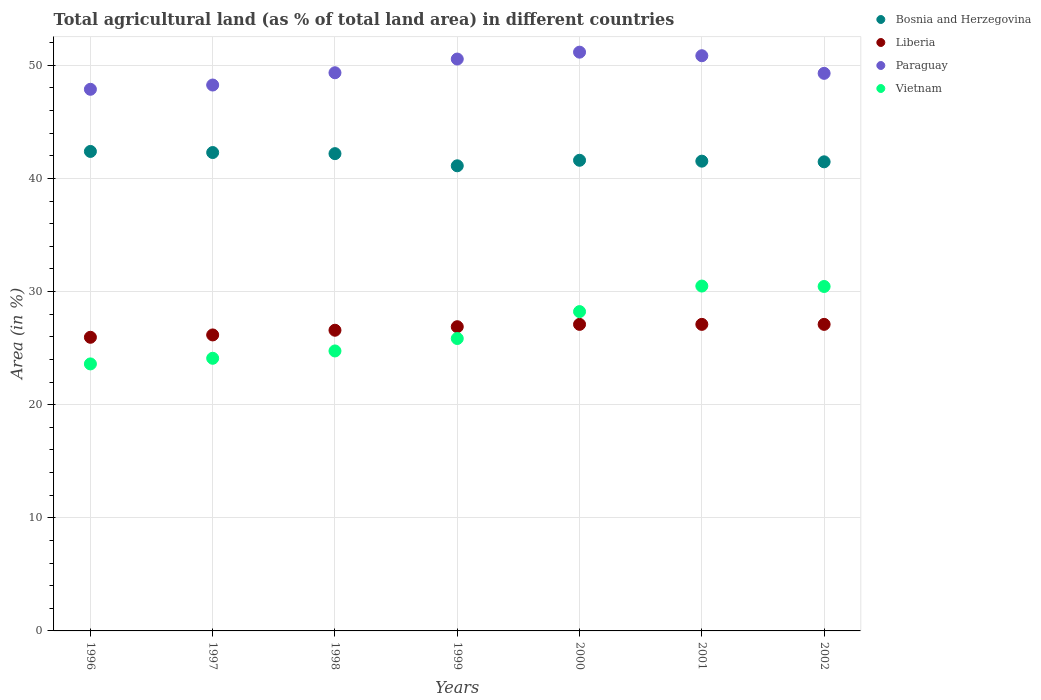How many different coloured dotlines are there?
Give a very brief answer. 4. Is the number of dotlines equal to the number of legend labels?
Provide a short and direct response. Yes. What is the percentage of agricultural land in Paraguay in 2002?
Make the answer very short. 49.29. Across all years, what is the maximum percentage of agricultural land in Vietnam?
Give a very brief answer. 30.48. Across all years, what is the minimum percentage of agricultural land in Liberia?
Provide a succinct answer. 25.96. In which year was the percentage of agricultural land in Paraguay maximum?
Your answer should be very brief. 2000. What is the total percentage of agricultural land in Paraguay in the graph?
Your answer should be compact. 347.3. What is the difference between the percentage of agricultural land in Paraguay in 2000 and that in 2002?
Your answer should be very brief. 1.87. What is the difference between the percentage of agricultural land in Vietnam in 1997 and the percentage of agricultural land in Paraguay in 2000?
Keep it short and to the point. -27.06. What is the average percentage of agricultural land in Vietnam per year?
Give a very brief answer. 26.78. In the year 1996, what is the difference between the percentage of agricultural land in Bosnia and Herzegovina and percentage of agricultural land in Liberia?
Ensure brevity in your answer.  16.43. What is the ratio of the percentage of agricultural land in Bosnia and Herzegovina in 1997 to that in 1998?
Your answer should be compact. 1. What is the difference between the highest and the lowest percentage of agricultural land in Paraguay?
Provide a succinct answer. 3.28. Is the percentage of agricultural land in Bosnia and Herzegovina strictly greater than the percentage of agricultural land in Vietnam over the years?
Your answer should be compact. Yes. Does the graph contain grids?
Make the answer very short. Yes. What is the title of the graph?
Your response must be concise. Total agricultural land (as % of total land area) in different countries. What is the label or title of the X-axis?
Offer a terse response. Years. What is the label or title of the Y-axis?
Provide a succinct answer. Area (in %). What is the Area (in %) in Bosnia and Herzegovina in 1996?
Your response must be concise. 42.38. What is the Area (in %) of Liberia in 1996?
Offer a very short reply. 25.96. What is the Area (in %) in Paraguay in 1996?
Your answer should be very brief. 47.88. What is the Area (in %) of Vietnam in 1996?
Keep it short and to the point. 23.6. What is the Area (in %) of Bosnia and Herzegovina in 1997?
Provide a succinct answer. 42.29. What is the Area (in %) of Liberia in 1997?
Your answer should be very brief. 26.16. What is the Area (in %) of Paraguay in 1997?
Your response must be concise. 48.25. What is the Area (in %) of Vietnam in 1997?
Your response must be concise. 24.1. What is the Area (in %) in Bosnia and Herzegovina in 1998?
Offer a very short reply. 42.19. What is the Area (in %) of Liberia in 1998?
Make the answer very short. 26.58. What is the Area (in %) of Paraguay in 1998?
Give a very brief answer. 49.34. What is the Area (in %) in Vietnam in 1998?
Make the answer very short. 24.75. What is the Area (in %) in Bosnia and Herzegovina in 1999?
Provide a succinct answer. 41.11. What is the Area (in %) of Liberia in 1999?
Your answer should be compact. 26.89. What is the Area (in %) in Paraguay in 1999?
Your answer should be very brief. 50.55. What is the Area (in %) in Vietnam in 1999?
Your answer should be very brief. 25.85. What is the Area (in %) in Bosnia and Herzegovina in 2000?
Offer a terse response. 41.6. What is the Area (in %) in Liberia in 2000?
Give a very brief answer. 27.1. What is the Area (in %) of Paraguay in 2000?
Ensure brevity in your answer.  51.16. What is the Area (in %) of Vietnam in 2000?
Your response must be concise. 28.23. What is the Area (in %) of Bosnia and Herzegovina in 2001?
Your answer should be compact. 41.52. What is the Area (in %) of Liberia in 2001?
Provide a short and direct response. 27.1. What is the Area (in %) of Paraguay in 2001?
Offer a very short reply. 50.84. What is the Area (in %) of Vietnam in 2001?
Your response must be concise. 30.48. What is the Area (in %) of Bosnia and Herzegovina in 2002?
Your response must be concise. 41.46. What is the Area (in %) in Liberia in 2002?
Ensure brevity in your answer.  27.1. What is the Area (in %) in Paraguay in 2002?
Offer a very short reply. 49.29. What is the Area (in %) of Vietnam in 2002?
Provide a succinct answer. 30.45. Across all years, what is the maximum Area (in %) in Bosnia and Herzegovina?
Offer a terse response. 42.38. Across all years, what is the maximum Area (in %) of Liberia?
Ensure brevity in your answer.  27.1. Across all years, what is the maximum Area (in %) of Paraguay?
Ensure brevity in your answer.  51.16. Across all years, what is the maximum Area (in %) of Vietnam?
Provide a succinct answer. 30.48. Across all years, what is the minimum Area (in %) of Bosnia and Herzegovina?
Offer a terse response. 41.11. Across all years, what is the minimum Area (in %) of Liberia?
Keep it short and to the point. 25.96. Across all years, what is the minimum Area (in %) of Paraguay?
Your answer should be very brief. 47.88. Across all years, what is the minimum Area (in %) in Vietnam?
Your answer should be very brief. 23.6. What is the total Area (in %) of Bosnia and Herzegovina in the graph?
Your response must be concise. 292.56. What is the total Area (in %) of Liberia in the graph?
Keep it short and to the point. 186.88. What is the total Area (in %) of Paraguay in the graph?
Ensure brevity in your answer.  347.3. What is the total Area (in %) of Vietnam in the graph?
Offer a terse response. 187.45. What is the difference between the Area (in %) in Bosnia and Herzegovina in 1996 and that in 1997?
Your answer should be very brief. 0.1. What is the difference between the Area (in %) of Liberia in 1996 and that in 1997?
Ensure brevity in your answer.  -0.21. What is the difference between the Area (in %) in Paraguay in 1996 and that in 1997?
Keep it short and to the point. -0.38. What is the difference between the Area (in %) in Vietnam in 1996 and that in 1997?
Give a very brief answer. -0.5. What is the difference between the Area (in %) in Bosnia and Herzegovina in 1996 and that in 1998?
Your response must be concise. 0.2. What is the difference between the Area (in %) in Liberia in 1996 and that in 1998?
Your answer should be compact. -0.62. What is the difference between the Area (in %) in Paraguay in 1996 and that in 1998?
Provide a succinct answer. -1.46. What is the difference between the Area (in %) in Vietnam in 1996 and that in 1998?
Ensure brevity in your answer.  -1.15. What is the difference between the Area (in %) of Bosnia and Herzegovina in 1996 and that in 1999?
Make the answer very short. 1.27. What is the difference between the Area (in %) of Liberia in 1996 and that in 1999?
Provide a short and direct response. -0.93. What is the difference between the Area (in %) in Paraguay in 1996 and that in 1999?
Offer a very short reply. -2.67. What is the difference between the Area (in %) of Vietnam in 1996 and that in 1999?
Provide a short and direct response. -2.25. What is the difference between the Area (in %) in Bosnia and Herzegovina in 1996 and that in 2000?
Provide a succinct answer. 0.78. What is the difference between the Area (in %) of Liberia in 1996 and that in 2000?
Make the answer very short. -1.14. What is the difference between the Area (in %) of Paraguay in 1996 and that in 2000?
Ensure brevity in your answer.  -3.28. What is the difference between the Area (in %) of Vietnam in 1996 and that in 2000?
Provide a succinct answer. -4.62. What is the difference between the Area (in %) of Bosnia and Herzegovina in 1996 and that in 2001?
Provide a short and direct response. 0.86. What is the difference between the Area (in %) in Liberia in 1996 and that in 2001?
Offer a very short reply. -1.14. What is the difference between the Area (in %) in Paraguay in 1996 and that in 2001?
Give a very brief answer. -2.97. What is the difference between the Area (in %) of Vietnam in 1996 and that in 2001?
Keep it short and to the point. -6.88. What is the difference between the Area (in %) of Bosnia and Herzegovina in 1996 and that in 2002?
Your response must be concise. 0.92. What is the difference between the Area (in %) in Liberia in 1996 and that in 2002?
Ensure brevity in your answer.  -1.14. What is the difference between the Area (in %) in Paraguay in 1996 and that in 2002?
Keep it short and to the point. -1.41. What is the difference between the Area (in %) in Vietnam in 1996 and that in 2002?
Ensure brevity in your answer.  -6.84. What is the difference between the Area (in %) of Bosnia and Herzegovina in 1997 and that in 1998?
Provide a succinct answer. 0.1. What is the difference between the Area (in %) in Liberia in 1997 and that in 1998?
Ensure brevity in your answer.  -0.42. What is the difference between the Area (in %) in Paraguay in 1997 and that in 1998?
Provide a short and direct response. -1.08. What is the difference between the Area (in %) in Vietnam in 1997 and that in 1998?
Give a very brief answer. -0.65. What is the difference between the Area (in %) of Bosnia and Herzegovina in 1997 and that in 1999?
Your answer should be very brief. 1.17. What is the difference between the Area (in %) in Liberia in 1997 and that in 1999?
Give a very brief answer. -0.73. What is the difference between the Area (in %) of Paraguay in 1997 and that in 1999?
Give a very brief answer. -2.3. What is the difference between the Area (in %) in Vietnam in 1997 and that in 1999?
Your answer should be compact. -1.75. What is the difference between the Area (in %) in Bosnia and Herzegovina in 1997 and that in 2000?
Keep it short and to the point. 0.68. What is the difference between the Area (in %) of Liberia in 1997 and that in 2000?
Offer a very short reply. -0.93. What is the difference between the Area (in %) in Paraguay in 1997 and that in 2000?
Provide a short and direct response. -2.9. What is the difference between the Area (in %) of Vietnam in 1997 and that in 2000?
Give a very brief answer. -4.13. What is the difference between the Area (in %) in Bosnia and Herzegovina in 1997 and that in 2001?
Keep it short and to the point. 0.76. What is the difference between the Area (in %) in Liberia in 1997 and that in 2001?
Your answer should be very brief. -0.93. What is the difference between the Area (in %) in Paraguay in 1997 and that in 2001?
Offer a terse response. -2.59. What is the difference between the Area (in %) in Vietnam in 1997 and that in 2001?
Make the answer very short. -6.38. What is the difference between the Area (in %) of Bosnia and Herzegovina in 1997 and that in 2002?
Offer a very short reply. 0.82. What is the difference between the Area (in %) of Liberia in 1997 and that in 2002?
Ensure brevity in your answer.  -0.93. What is the difference between the Area (in %) in Paraguay in 1997 and that in 2002?
Keep it short and to the point. -1.03. What is the difference between the Area (in %) in Vietnam in 1997 and that in 2002?
Make the answer very short. -6.35. What is the difference between the Area (in %) of Bosnia and Herzegovina in 1998 and that in 1999?
Provide a short and direct response. 1.07. What is the difference between the Area (in %) of Liberia in 1998 and that in 1999?
Provide a succinct answer. -0.31. What is the difference between the Area (in %) of Paraguay in 1998 and that in 1999?
Your response must be concise. -1.21. What is the difference between the Area (in %) in Vietnam in 1998 and that in 1999?
Give a very brief answer. -1.1. What is the difference between the Area (in %) of Bosnia and Herzegovina in 1998 and that in 2000?
Keep it short and to the point. 0.59. What is the difference between the Area (in %) of Liberia in 1998 and that in 2000?
Your answer should be compact. -0.52. What is the difference between the Area (in %) in Paraguay in 1998 and that in 2000?
Offer a very short reply. -1.82. What is the difference between the Area (in %) in Vietnam in 1998 and that in 2000?
Ensure brevity in your answer.  -3.48. What is the difference between the Area (in %) of Bosnia and Herzegovina in 1998 and that in 2001?
Your response must be concise. 0.66. What is the difference between the Area (in %) in Liberia in 1998 and that in 2001?
Keep it short and to the point. -0.52. What is the difference between the Area (in %) of Paraguay in 1998 and that in 2001?
Give a very brief answer. -1.51. What is the difference between the Area (in %) of Vietnam in 1998 and that in 2001?
Provide a short and direct response. -5.74. What is the difference between the Area (in %) of Bosnia and Herzegovina in 1998 and that in 2002?
Offer a very short reply. 0.72. What is the difference between the Area (in %) of Liberia in 1998 and that in 2002?
Ensure brevity in your answer.  -0.52. What is the difference between the Area (in %) of Paraguay in 1998 and that in 2002?
Ensure brevity in your answer.  0.05. What is the difference between the Area (in %) of Vietnam in 1998 and that in 2002?
Your answer should be very brief. -5.7. What is the difference between the Area (in %) in Bosnia and Herzegovina in 1999 and that in 2000?
Your response must be concise. -0.49. What is the difference between the Area (in %) of Liberia in 1999 and that in 2000?
Your answer should be compact. -0.21. What is the difference between the Area (in %) of Paraguay in 1999 and that in 2000?
Your answer should be compact. -0.61. What is the difference between the Area (in %) of Vietnam in 1999 and that in 2000?
Your answer should be compact. -2.38. What is the difference between the Area (in %) of Bosnia and Herzegovina in 1999 and that in 2001?
Provide a succinct answer. -0.41. What is the difference between the Area (in %) of Liberia in 1999 and that in 2001?
Keep it short and to the point. -0.21. What is the difference between the Area (in %) of Paraguay in 1999 and that in 2001?
Give a very brief answer. -0.29. What is the difference between the Area (in %) of Vietnam in 1999 and that in 2001?
Offer a terse response. -4.64. What is the difference between the Area (in %) in Bosnia and Herzegovina in 1999 and that in 2002?
Keep it short and to the point. -0.35. What is the difference between the Area (in %) of Liberia in 1999 and that in 2002?
Provide a succinct answer. -0.21. What is the difference between the Area (in %) of Paraguay in 1999 and that in 2002?
Your answer should be very brief. 1.26. What is the difference between the Area (in %) in Vietnam in 1999 and that in 2002?
Your answer should be very brief. -4.6. What is the difference between the Area (in %) of Bosnia and Herzegovina in 2000 and that in 2001?
Keep it short and to the point. 0.08. What is the difference between the Area (in %) of Liberia in 2000 and that in 2001?
Offer a very short reply. 0. What is the difference between the Area (in %) in Paraguay in 2000 and that in 2001?
Your response must be concise. 0.31. What is the difference between the Area (in %) in Vietnam in 2000 and that in 2001?
Offer a very short reply. -2.26. What is the difference between the Area (in %) in Bosnia and Herzegovina in 2000 and that in 2002?
Your answer should be compact. 0.14. What is the difference between the Area (in %) in Liberia in 2000 and that in 2002?
Ensure brevity in your answer.  0. What is the difference between the Area (in %) of Paraguay in 2000 and that in 2002?
Provide a short and direct response. 1.87. What is the difference between the Area (in %) in Vietnam in 2000 and that in 2002?
Your answer should be very brief. -2.22. What is the difference between the Area (in %) of Bosnia and Herzegovina in 2001 and that in 2002?
Your response must be concise. 0.06. What is the difference between the Area (in %) in Liberia in 2001 and that in 2002?
Provide a short and direct response. 0. What is the difference between the Area (in %) in Paraguay in 2001 and that in 2002?
Offer a very short reply. 1.56. What is the difference between the Area (in %) of Vietnam in 2001 and that in 2002?
Provide a short and direct response. 0.04. What is the difference between the Area (in %) of Bosnia and Herzegovina in 1996 and the Area (in %) of Liberia in 1997?
Provide a short and direct response. 16.22. What is the difference between the Area (in %) of Bosnia and Herzegovina in 1996 and the Area (in %) of Paraguay in 1997?
Offer a terse response. -5.87. What is the difference between the Area (in %) of Bosnia and Herzegovina in 1996 and the Area (in %) of Vietnam in 1997?
Your answer should be compact. 18.28. What is the difference between the Area (in %) of Liberia in 1996 and the Area (in %) of Paraguay in 1997?
Offer a very short reply. -22.3. What is the difference between the Area (in %) in Liberia in 1996 and the Area (in %) in Vietnam in 1997?
Make the answer very short. 1.86. What is the difference between the Area (in %) of Paraguay in 1996 and the Area (in %) of Vietnam in 1997?
Your answer should be compact. 23.78. What is the difference between the Area (in %) of Bosnia and Herzegovina in 1996 and the Area (in %) of Liberia in 1998?
Provide a short and direct response. 15.8. What is the difference between the Area (in %) of Bosnia and Herzegovina in 1996 and the Area (in %) of Paraguay in 1998?
Your response must be concise. -6.96. What is the difference between the Area (in %) in Bosnia and Herzegovina in 1996 and the Area (in %) in Vietnam in 1998?
Your response must be concise. 17.64. What is the difference between the Area (in %) in Liberia in 1996 and the Area (in %) in Paraguay in 1998?
Give a very brief answer. -23.38. What is the difference between the Area (in %) of Liberia in 1996 and the Area (in %) of Vietnam in 1998?
Your answer should be compact. 1.21. What is the difference between the Area (in %) in Paraguay in 1996 and the Area (in %) in Vietnam in 1998?
Your response must be concise. 23.13. What is the difference between the Area (in %) of Bosnia and Herzegovina in 1996 and the Area (in %) of Liberia in 1999?
Provide a short and direct response. 15.49. What is the difference between the Area (in %) in Bosnia and Herzegovina in 1996 and the Area (in %) in Paraguay in 1999?
Your response must be concise. -8.17. What is the difference between the Area (in %) in Bosnia and Herzegovina in 1996 and the Area (in %) in Vietnam in 1999?
Your answer should be very brief. 16.54. What is the difference between the Area (in %) in Liberia in 1996 and the Area (in %) in Paraguay in 1999?
Give a very brief answer. -24.59. What is the difference between the Area (in %) of Liberia in 1996 and the Area (in %) of Vietnam in 1999?
Your answer should be compact. 0.11. What is the difference between the Area (in %) of Paraguay in 1996 and the Area (in %) of Vietnam in 1999?
Offer a very short reply. 22.03. What is the difference between the Area (in %) in Bosnia and Herzegovina in 1996 and the Area (in %) in Liberia in 2000?
Keep it short and to the point. 15.29. What is the difference between the Area (in %) in Bosnia and Herzegovina in 1996 and the Area (in %) in Paraguay in 2000?
Provide a succinct answer. -8.78. What is the difference between the Area (in %) in Bosnia and Herzegovina in 1996 and the Area (in %) in Vietnam in 2000?
Your answer should be compact. 14.16. What is the difference between the Area (in %) in Liberia in 1996 and the Area (in %) in Paraguay in 2000?
Provide a succinct answer. -25.2. What is the difference between the Area (in %) of Liberia in 1996 and the Area (in %) of Vietnam in 2000?
Your answer should be very brief. -2.27. What is the difference between the Area (in %) in Paraguay in 1996 and the Area (in %) in Vietnam in 2000?
Provide a short and direct response. 19.65. What is the difference between the Area (in %) in Bosnia and Herzegovina in 1996 and the Area (in %) in Liberia in 2001?
Provide a succinct answer. 15.29. What is the difference between the Area (in %) of Bosnia and Herzegovina in 1996 and the Area (in %) of Paraguay in 2001?
Ensure brevity in your answer.  -8.46. What is the difference between the Area (in %) in Bosnia and Herzegovina in 1996 and the Area (in %) in Vietnam in 2001?
Provide a succinct answer. 11.9. What is the difference between the Area (in %) of Liberia in 1996 and the Area (in %) of Paraguay in 2001?
Your answer should be very brief. -24.89. What is the difference between the Area (in %) in Liberia in 1996 and the Area (in %) in Vietnam in 2001?
Your answer should be very brief. -4.53. What is the difference between the Area (in %) of Paraguay in 1996 and the Area (in %) of Vietnam in 2001?
Your answer should be compact. 17.39. What is the difference between the Area (in %) of Bosnia and Herzegovina in 1996 and the Area (in %) of Liberia in 2002?
Ensure brevity in your answer.  15.29. What is the difference between the Area (in %) in Bosnia and Herzegovina in 1996 and the Area (in %) in Paraguay in 2002?
Make the answer very short. -6.9. What is the difference between the Area (in %) of Bosnia and Herzegovina in 1996 and the Area (in %) of Vietnam in 2002?
Keep it short and to the point. 11.94. What is the difference between the Area (in %) of Liberia in 1996 and the Area (in %) of Paraguay in 2002?
Offer a terse response. -23.33. What is the difference between the Area (in %) of Liberia in 1996 and the Area (in %) of Vietnam in 2002?
Your answer should be compact. -4.49. What is the difference between the Area (in %) of Paraguay in 1996 and the Area (in %) of Vietnam in 2002?
Your response must be concise. 17.43. What is the difference between the Area (in %) of Bosnia and Herzegovina in 1997 and the Area (in %) of Liberia in 1998?
Make the answer very short. 15.71. What is the difference between the Area (in %) of Bosnia and Herzegovina in 1997 and the Area (in %) of Paraguay in 1998?
Give a very brief answer. -7.05. What is the difference between the Area (in %) of Bosnia and Herzegovina in 1997 and the Area (in %) of Vietnam in 1998?
Your answer should be compact. 17.54. What is the difference between the Area (in %) of Liberia in 1997 and the Area (in %) of Paraguay in 1998?
Offer a terse response. -23.18. What is the difference between the Area (in %) in Liberia in 1997 and the Area (in %) in Vietnam in 1998?
Make the answer very short. 1.42. What is the difference between the Area (in %) in Paraguay in 1997 and the Area (in %) in Vietnam in 1998?
Keep it short and to the point. 23.51. What is the difference between the Area (in %) of Bosnia and Herzegovina in 1997 and the Area (in %) of Liberia in 1999?
Provide a succinct answer. 15.4. What is the difference between the Area (in %) in Bosnia and Herzegovina in 1997 and the Area (in %) in Paraguay in 1999?
Provide a succinct answer. -8.26. What is the difference between the Area (in %) in Bosnia and Herzegovina in 1997 and the Area (in %) in Vietnam in 1999?
Your response must be concise. 16.44. What is the difference between the Area (in %) of Liberia in 1997 and the Area (in %) of Paraguay in 1999?
Make the answer very short. -24.39. What is the difference between the Area (in %) in Liberia in 1997 and the Area (in %) in Vietnam in 1999?
Provide a succinct answer. 0.32. What is the difference between the Area (in %) in Paraguay in 1997 and the Area (in %) in Vietnam in 1999?
Keep it short and to the point. 22.41. What is the difference between the Area (in %) of Bosnia and Herzegovina in 1997 and the Area (in %) of Liberia in 2000?
Make the answer very short. 15.19. What is the difference between the Area (in %) of Bosnia and Herzegovina in 1997 and the Area (in %) of Paraguay in 2000?
Your answer should be very brief. -8.87. What is the difference between the Area (in %) in Bosnia and Herzegovina in 1997 and the Area (in %) in Vietnam in 2000?
Your answer should be very brief. 14.06. What is the difference between the Area (in %) in Liberia in 1997 and the Area (in %) in Paraguay in 2000?
Your answer should be very brief. -25. What is the difference between the Area (in %) in Liberia in 1997 and the Area (in %) in Vietnam in 2000?
Your answer should be compact. -2.06. What is the difference between the Area (in %) of Paraguay in 1997 and the Area (in %) of Vietnam in 2000?
Provide a short and direct response. 20.03. What is the difference between the Area (in %) in Bosnia and Herzegovina in 1997 and the Area (in %) in Liberia in 2001?
Give a very brief answer. 15.19. What is the difference between the Area (in %) of Bosnia and Herzegovina in 1997 and the Area (in %) of Paraguay in 2001?
Provide a succinct answer. -8.56. What is the difference between the Area (in %) of Bosnia and Herzegovina in 1997 and the Area (in %) of Vietnam in 2001?
Ensure brevity in your answer.  11.8. What is the difference between the Area (in %) in Liberia in 1997 and the Area (in %) in Paraguay in 2001?
Your answer should be compact. -24.68. What is the difference between the Area (in %) of Liberia in 1997 and the Area (in %) of Vietnam in 2001?
Provide a short and direct response. -4.32. What is the difference between the Area (in %) of Paraguay in 1997 and the Area (in %) of Vietnam in 2001?
Provide a short and direct response. 17.77. What is the difference between the Area (in %) of Bosnia and Herzegovina in 1997 and the Area (in %) of Liberia in 2002?
Provide a short and direct response. 15.19. What is the difference between the Area (in %) in Bosnia and Herzegovina in 1997 and the Area (in %) in Paraguay in 2002?
Keep it short and to the point. -7. What is the difference between the Area (in %) in Bosnia and Herzegovina in 1997 and the Area (in %) in Vietnam in 2002?
Give a very brief answer. 11.84. What is the difference between the Area (in %) of Liberia in 1997 and the Area (in %) of Paraguay in 2002?
Your answer should be compact. -23.12. What is the difference between the Area (in %) in Liberia in 1997 and the Area (in %) in Vietnam in 2002?
Your answer should be very brief. -4.28. What is the difference between the Area (in %) in Paraguay in 1997 and the Area (in %) in Vietnam in 2002?
Provide a short and direct response. 17.81. What is the difference between the Area (in %) in Bosnia and Herzegovina in 1998 and the Area (in %) in Liberia in 1999?
Keep it short and to the point. 15.3. What is the difference between the Area (in %) in Bosnia and Herzegovina in 1998 and the Area (in %) in Paraguay in 1999?
Offer a very short reply. -8.36. What is the difference between the Area (in %) of Bosnia and Herzegovina in 1998 and the Area (in %) of Vietnam in 1999?
Your answer should be very brief. 16.34. What is the difference between the Area (in %) of Liberia in 1998 and the Area (in %) of Paraguay in 1999?
Your answer should be compact. -23.97. What is the difference between the Area (in %) of Liberia in 1998 and the Area (in %) of Vietnam in 1999?
Provide a short and direct response. 0.73. What is the difference between the Area (in %) of Paraguay in 1998 and the Area (in %) of Vietnam in 1999?
Your response must be concise. 23.49. What is the difference between the Area (in %) in Bosnia and Herzegovina in 1998 and the Area (in %) in Liberia in 2000?
Provide a short and direct response. 15.09. What is the difference between the Area (in %) in Bosnia and Herzegovina in 1998 and the Area (in %) in Paraguay in 2000?
Your answer should be very brief. -8.97. What is the difference between the Area (in %) of Bosnia and Herzegovina in 1998 and the Area (in %) of Vietnam in 2000?
Your response must be concise. 13.96. What is the difference between the Area (in %) of Liberia in 1998 and the Area (in %) of Paraguay in 2000?
Provide a succinct answer. -24.58. What is the difference between the Area (in %) of Liberia in 1998 and the Area (in %) of Vietnam in 2000?
Give a very brief answer. -1.65. What is the difference between the Area (in %) of Paraguay in 1998 and the Area (in %) of Vietnam in 2000?
Give a very brief answer. 21.11. What is the difference between the Area (in %) in Bosnia and Herzegovina in 1998 and the Area (in %) in Liberia in 2001?
Keep it short and to the point. 15.09. What is the difference between the Area (in %) in Bosnia and Herzegovina in 1998 and the Area (in %) in Paraguay in 2001?
Provide a succinct answer. -8.66. What is the difference between the Area (in %) in Bosnia and Herzegovina in 1998 and the Area (in %) in Vietnam in 2001?
Provide a short and direct response. 11.7. What is the difference between the Area (in %) in Liberia in 1998 and the Area (in %) in Paraguay in 2001?
Make the answer very short. -24.27. What is the difference between the Area (in %) of Liberia in 1998 and the Area (in %) of Vietnam in 2001?
Offer a terse response. -3.91. What is the difference between the Area (in %) of Paraguay in 1998 and the Area (in %) of Vietnam in 2001?
Your response must be concise. 18.85. What is the difference between the Area (in %) in Bosnia and Herzegovina in 1998 and the Area (in %) in Liberia in 2002?
Provide a short and direct response. 15.09. What is the difference between the Area (in %) in Bosnia and Herzegovina in 1998 and the Area (in %) in Paraguay in 2002?
Offer a very short reply. -7.1. What is the difference between the Area (in %) in Bosnia and Herzegovina in 1998 and the Area (in %) in Vietnam in 2002?
Offer a terse response. 11.74. What is the difference between the Area (in %) in Liberia in 1998 and the Area (in %) in Paraguay in 2002?
Your response must be concise. -22.71. What is the difference between the Area (in %) in Liberia in 1998 and the Area (in %) in Vietnam in 2002?
Your response must be concise. -3.87. What is the difference between the Area (in %) of Paraguay in 1998 and the Area (in %) of Vietnam in 2002?
Give a very brief answer. 18.89. What is the difference between the Area (in %) in Bosnia and Herzegovina in 1999 and the Area (in %) in Liberia in 2000?
Provide a short and direct response. 14.02. What is the difference between the Area (in %) in Bosnia and Herzegovina in 1999 and the Area (in %) in Paraguay in 2000?
Offer a very short reply. -10.04. What is the difference between the Area (in %) of Bosnia and Herzegovina in 1999 and the Area (in %) of Vietnam in 2000?
Your answer should be compact. 12.89. What is the difference between the Area (in %) in Liberia in 1999 and the Area (in %) in Paraguay in 2000?
Provide a succinct answer. -24.27. What is the difference between the Area (in %) in Liberia in 1999 and the Area (in %) in Vietnam in 2000?
Give a very brief answer. -1.34. What is the difference between the Area (in %) in Paraguay in 1999 and the Area (in %) in Vietnam in 2000?
Give a very brief answer. 22.32. What is the difference between the Area (in %) of Bosnia and Herzegovina in 1999 and the Area (in %) of Liberia in 2001?
Your answer should be very brief. 14.02. What is the difference between the Area (in %) of Bosnia and Herzegovina in 1999 and the Area (in %) of Paraguay in 2001?
Offer a terse response. -9.73. What is the difference between the Area (in %) in Bosnia and Herzegovina in 1999 and the Area (in %) in Vietnam in 2001?
Your answer should be very brief. 10.63. What is the difference between the Area (in %) in Liberia in 1999 and the Area (in %) in Paraguay in 2001?
Offer a terse response. -23.95. What is the difference between the Area (in %) of Liberia in 1999 and the Area (in %) of Vietnam in 2001?
Make the answer very short. -3.59. What is the difference between the Area (in %) in Paraguay in 1999 and the Area (in %) in Vietnam in 2001?
Provide a succinct answer. 20.07. What is the difference between the Area (in %) in Bosnia and Herzegovina in 1999 and the Area (in %) in Liberia in 2002?
Your answer should be very brief. 14.02. What is the difference between the Area (in %) in Bosnia and Herzegovina in 1999 and the Area (in %) in Paraguay in 2002?
Make the answer very short. -8.17. What is the difference between the Area (in %) in Bosnia and Herzegovina in 1999 and the Area (in %) in Vietnam in 2002?
Provide a short and direct response. 10.67. What is the difference between the Area (in %) in Liberia in 1999 and the Area (in %) in Paraguay in 2002?
Keep it short and to the point. -22.4. What is the difference between the Area (in %) in Liberia in 1999 and the Area (in %) in Vietnam in 2002?
Your response must be concise. -3.56. What is the difference between the Area (in %) in Paraguay in 1999 and the Area (in %) in Vietnam in 2002?
Provide a short and direct response. 20.1. What is the difference between the Area (in %) of Bosnia and Herzegovina in 2000 and the Area (in %) of Liberia in 2001?
Make the answer very short. 14.5. What is the difference between the Area (in %) of Bosnia and Herzegovina in 2000 and the Area (in %) of Paraguay in 2001?
Your answer should be very brief. -9.24. What is the difference between the Area (in %) in Bosnia and Herzegovina in 2000 and the Area (in %) in Vietnam in 2001?
Your answer should be compact. 11.12. What is the difference between the Area (in %) in Liberia in 2000 and the Area (in %) in Paraguay in 2001?
Provide a succinct answer. -23.75. What is the difference between the Area (in %) in Liberia in 2000 and the Area (in %) in Vietnam in 2001?
Make the answer very short. -3.39. What is the difference between the Area (in %) of Paraguay in 2000 and the Area (in %) of Vietnam in 2001?
Ensure brevity in your answer.  20.67. What is the difference between the Area (in %) of Bosnia and Herzegovina in 2000 and the Area (in %) of Liberia in 2002?
Your answer should be very brief. 14.5. What is the difference between the Area (in %) of Bosnia and Herzegovina in 2000 and the Area (in %) of Paraguay in 2002?
Make the answer very short. -7.68. What is the difference between the Area (in %) of Bosnia and Herzegovina in 2000 and the Area (in %) of Vietnam in 2002?
Provide a short and direct response. 11.16. What is the difference between the Area (in %) of Liberia in 2000 and the Area (in %) of Paraguay in 2002?
Ensure brevity in your answer.  -22.19. What is the difference between the Area (in %) in Liberia in 2000 and the Area (in %) in Vietnam in 2002?
Provide a succinct answer. -3.35. What is the difference between the Area (in %) in Paraguay in 2000 and the Area (in %) in Vietnam in 2002?
Your answer should be compact. 20.71. What is the difference between the Area (in %) of Bosnia and Herzegovina in 2001 and the Area (in %) of Liberia in 2002?
Your answer should be compact. 14.43. What is the difference between the Area (in %) of Bosnia and Herzegovina in 2001 and the Area (in %) of Paraguay in 2002?
Provide a short and direct response. -7.76. What is the difference between the Area (in %) in Bosnia and Herzegovina in 2001 and the Area (in %) in Vietnam in 2002?
Your answer should be compact. 11.08. What is the difference between the Area (in %) of Liberia in 2001 and the Area (in %) of Paraguay in 2002?
Your answer should be compact. -22.19. What is the difference between the Area (in %) in Liberia in 2001 and the Area (in %) in Vietnam in 2002?
Make the answer very short. -3.35. What is the difference between the Area (in %) of Paraguay in 2001 and the Area (in %) of Vietnam in 2002?
Provide a succinct answer. 20.4. What is the average Area (in %) of Bosnia and Herzegovina per year?
Give a very brief answer. 41.79. What is the average Area (in %) in Liberia per year?
Give a very brief answer. 26.7. What is the average Area (in %) in Paraguay per year?
Your response must be concise. 49.61. What is the average Area (in %) of Vietnam per year?
Your response must be concise. 26.78. In the year 1996, what is the difference between the Area (in %) of Bosnia and Herzegovina and Area (in %) of Liberia?
Your answer should be very brief. 16.43. In the year 1996, what is the difference between the Area (in %) of Bosnia and Herzegovina and Area (in %) of Paraguay?
Provide a short and direct response. -5.49. In the year 1996, what is the difference between the Area (in %) of Bosnia and Herzegovina and Area (in %) of Vietnam?
Provide a short and direct response. 18.78. In the year 1996, what is the difference between the Area (in %) in Liberia and Area (in %) in Paraguay?
Keep it short and to the point. -21.92. In the year 1996, what is the difference between the Area (in %) of Liberia and Area (in %) of Vietnam?
Keep it short and to the point. 2.35. In the year 1996, what is the difference between the Area (in %) of Paraguay and Area (in %) of Vietnam?
Your answer should be very brief. 24.27. In the year 1997, what is the difference between the Area (in %) of Bosnia and Herzegovina and Area (in %) of Liberia?
Provide a short and direct response. 16.12. In the year 1997, what is the difference between the Area (in %) in Bosnia and Herzegovina and Area (in %) in Paraguay?
Your answer should be compact. -5.97. In the year 1997, what is the difference between the Area (in %) in Bosnia and Herzegovina and Area (in %) in Vietnam?
Make the answer very short. 18.19. In the year 1997, what is the difference between the Area (in %) of Liberia and Area (in %) of Paraguay?
Make the answer very short. -22.09. In the year 1997, what is the difference between the Area (in %) in Liberia and Area (in %) in Vietnam?
Give a very brief answer. 2.06. In the year 1997, what is the difference between the Area (in %) of Paraguay and Area (in %) of Vietnam?
Offer a terse response. 24.15. In the year 1998, what is the difference between the Area (in %) in Bosnia and Herzegovina and Area (in %) in Liberia?
Give a very brief answer. 15.61. In the year 1998, what is the difference between the Area (in %) in Bosnia and Herzegovina and Area (in %) in Paraguay?
Offer a terse response. -7.15. In the year 1998, what is the difference between the Area (in %) in Bosnia and Herzegovina and Area (in %) in Vietnam?
Your response must be concise. 17.44. In the year 1998, what is the difference between the Area (in %) of Liberia and Area (in %) of Paraguay?
Your answer should be very brief. -22.76. In the year 1998, what is the difference between the Area (in %) of Liberia and Area (in %) of Vietnam?
Keep it short and to the point. 1.83. In the year 1998, what is the difference between the Area (in %) of Paraguay and Area (in %) of Vietnam?
Provide a short and direct response. 24.59. In the year 1999, what is the difference between the Area (in %) in Bosnia and Herzegovina and Area (in %) in Liberia?
Offer a very short reply. 14.22. In the year 1999, what is the difference between the Area (in %) in Bosnia and Herzegovina and Area (in %) in Paraguay?
Your response must be concise. -9.44. In the year 1999, what is the difference between the Area (in %) of Bosnia and Herzegovina and Area (in %) of Vietnam?
Offer a very short reply. 15.27. In the year 1999, what is the difference between the Area (in %) of Liberia and Area (in %) of Paraguay?
Keep it short and to the point. -23.66. In the year 1999, what is the difference between the Area (in %) in Liberia and Area (in %) in Vietnam?
Your answer should be compact. 1.04. In the year 1999, what is the difference between the Area (in %) in Paraguay and Area (in %) in Vietnam?
Offer a terse response. 24.7. In the year 2000, what is the difference between the Area (in %) of Bosnia and Herzegovina and Area (in %) of Liberia?
Your response must be concise. 14.5. In the year 2000, what is the difference between the Area (in %) of Bosnia and Herzegovina and Area (in %) of Paraguay?
Provide a short and direct response. -9.56. In the year 2000, what is the difference between the Area (in %) of Bosnia and Herzegovina and Area (in %) of Vietnam?
Offer a terse response. 13.38. In the year 2000, what is the difference between the Area (in %) in Liberia and Area (in %) in Paraguay?
Provide a short and direct response. -24.06. In the year 2000, what is the difference between the Area (in %) in Liberia and Area (in %) in Vietnam?
Ensure brevity in your answer.  -1.13. In the year 2000, what is the difference between the Area (in %) of Paraguay and Area (in %) of Vietnam?
Give a very brief answer. 22.93. In the year 2001, what is the difference between the Area (in %) in Bosnia and Herzegovina and Area (in %) in Liberia?
Your answer should be compact. 14.43. In the year 2001, what is the difference between the Area (in %) of Bosnia and Herzegovina and Area (in %) of Paraguay?
Provide a short and direct response. -9.32. In the year 2001, what is the difference between the Area (in %) of Bosnia and Herzegovina and Area (in %) of Vietnam?
Offer a very short reply. 11.04. In the year 2001, what is the difference between the Area (in %) in Liberia and Area (in %) in Paraguay?
Keep it short and to the point. -23.75. In the year 2001, what is the difference between the Area (in %) in Liberia and Area (in %) in Vietnam?
Offer a terse response. -3.39. In the year 2001, what is the difference between the Area (in %) in Paraguay and Area (in %) in Vietnam?
Your answer should be very brief. 20.36. In the year 2002, what is the difference between the Area (in %) of Bosnia and Herzegovina and Area (in %) of Liberia?
Ensure brevity in your answer.  14.37. In the year 2002, what is the difference between the Area (in %) of Bosnia and Herzegovina and Area (in %) of Paraguay?
Offer a very short reply. -7.82. In the year 2002, what is the difference between the Area (in %) of Bosnia and Herzegovina and Area (in %) of Vietnam?
Provide a short and direct response. 11.02. In the year 2002, what is the difference between the Area (in %) of Liberia and Area (in %) of Paraguay?
Ensure brevity in your answer.  -22.19. In the year 2002, what is the difference between the Area (in %) in Liberia and Area (in %) in Vietnam?
Your response must be concise. -3.35. In the year 2002, what is the difference between the Area (in %) in Paraguay and Area (in %) in Vietnam?
Your response must be concise. 18.84. What is the ratio of the Area (in %) of Bosnia and Herzegovina in 1996 to that in 1997?
Your response must be concise. 1. What is the ratio of the Area (in %) of Vietnam in 1996 to that in 1997?
Make the answer very short. 0.98. What is the ratio of the Area (in %) in Bosnia and Herzegovina in 1996 to that in 1998?
Provide a succinct answer. 1. What is the ratio of the Area (in %) of Liberia in 1996 to that in 1998?
Give a very brief answer. 0.98. What is the ratio of the Area (in %) of Paraguay in 1996 to that in 1998?
Offer a terse response. 0.97. What is the ratio of the Area (in %) of Vietnam in 1996 to that in 1998?
Provide a short and direct response. 0.95. What is the ratio of the Area (in %) in Bosnia and Herzegovina in 1996 to that in 1999?
Offer a terse response. 1.03. What is the ratio of the Area (in %) in Liberia in 1996 to that in 1999?
Provide a succinct answer. 0.97. What is the ratio of the Area (in %) in Paraguay in 1996 to that in 1999?
Offer a very short reply. 0.95. What is the ratio of the Area (in %) in Vietnam in 1996 to that in 1999?
Provide a short and direct response. 0.91. What is the ratio of the Area (in %) of Bosnia and Herzegovina in 1996 to that in 2000?
Ensure brevity in your answer.  1.02. What is the ratio of the Area (in %) of Liberia in 1996 to that in 2000?
Your answer should be very brief. 0.96. What is the ratio of the Area (in %) of Paraguay in 1996 to that in 2000?
Your answer should be compact. 0.94. What is the ratio of the Area (in %) in Vietnam in 1996 to that in 2000?
Provide a succinct answer. 0.84. What is the ratio of the Area (in %) of Bosnia and Herzegovina in 1996 to that in 2001?
Keep it short and to the point. 1.02. What is the ratio of the Area (in %) of Liberia in 1996 to that in 2001?
Offer a very short reply. 0.96. What is the ratio of the Area (in %) in Paraguay in 1996 to that in 2001?
Offer a very short reply. 0.94. What is the ratio of the Area (in %) of Vietnam in 1996 to that in 2001?
Keep it short and to the point. 0.77. What is the ratio of the Area (in %) in Bosnia and Herzegovina in 1996 to that in 2002?
Your answer should be compact. 1.02. What is the ratio of the Area (in %) of Liberia in 1996 to that in 2002?
Your response must be concise. 0.96. What is the ratio of the Area (in %) of Paraguay in 1996 to that in 2002?
Offer a terse response. 0.97. What is the ratio of the Area (in %) in Vietnam in 1996 to that in 2002?
Offer a terse response. 0.78. What is the ratio of the Area (in %) in Bosnia and Herzegovina in 1997 to that in 1998?
Your answer should be very brief. 1. What is the ratio of the Area (in %) of Liberia in 1997 to that in 1998?
Make the answer very short. 0.98. What is the ratio of the Area (in %) of Vietnam in 1997 to that in 1998?
Offer a terse response. 0.97. What is the ratio of the Area (in %) of Bosnia and Herzegovina in 1997 to that in 1999?
Your response must be concise. 1.03. What is the ratio of the Area (in %) in Liberia in 1997 to that in 1999?
Your answer should be very brief. 0.97. What is the ratio of the Area (in %) of Paraguay in 1997 to that in 1999?
Offer a terse response. 0.95. What is the ratio of the Area (in %) in Vietnam in 1997 to that in 1999?
Keep it short and to the point. 0.93. What is the ratio of the Area (in %) of Bosnia and Herzegovina in 1997 to that in 2000?
Your answer should be very brief. 1.02. What is the ratio of the Area (in %) of Liberia in 1997 to that in 2000?
Provide a short and direct response. 0.97. What is the ratio of the Area (in %) in Paraguay in 1997 to that in 2000?
Your response must be concise. 0.94. What is the ratio of the Area (in %) of Vietnam in 1997 to that in 2000?
Keep it short and to the point. 0.85. What is the ratio of the Area (in %) of Bosnia and Herzegovina in 1997 to that in 2001?
Offer a terse response. 1.02. What is the ratio of the Area (in %) in Liberia in 1997 to that in 2001?
Your answer should be very brief. 0.97. What is the ratio of the Area (in %) of Paraguay in 1997 to that in 2001?
Offer a very short reply. 0.95. What is the ratio of the Area (in %) of Vietnam in 1997 to that in 2001?
Your response must be concise. 0.79. What is the ratio of the Area (in %) of Bosnia and Herzegovina in 1997 to that in 2002?
Your response must be concise. 1.02. What is the ratio of the Area (in %) of Liberia in 1997 to that in 2002?
Make the answer very short. 0.97. What is the ratio of the Area (in %) of Paraguay in 1997 to that in 2002?
Give a very brief answer. 0.98. What is the ratio of the Area (in %) of Vietnam in 1997 to that in 2002?
Keep it short and to the point. 0.79. What is the ratio of the Area (in %) of Bosnia and Herzegovina in 1998 to that in 1999?
Give a very brief answer. 1.03. What is the ratio of the Area (in %) of Liberia in 1998 to that in 1999?
Your answer should be compact. 0.99. What is the ratio of the Area (in %) of Vietnam in 1998 to that in 1999?
Your response must be concise. 0.96. What is the ratio of the Area (in %) in Bosnia and Herzegovina in 1998 to that in 2000?
Your answer should be compact. 1.01. What is the ratio of the Area (in %) of Liberia in 1998 to that in 2000?
Ensure brevity in your answer.  0.98. What is the ratio of the Area (in %) in Paraguay in 1998 to that in 2000?
Give a very brief answer. 0.96. What is the ratio of the Area (in %) in Vietnam in 1998 to that in 2000?
Make the answer very short. 0.88. What is the ratio of the Area (in %) of Liberia in 1998 to that in 2001?
Offer a terse response. 0.98. What is the ratio of the Area (in %) in Paraguay in 1998 to that in 2001?
Your response must be concise. 0.97. What is the ratio of the Area (in %) in Vietnam in 1998 to that in 2001?
Offer a very short reply. 0.81. What is the ratio of the Area (in %) in Bosnia and Herzegovina in 1998 to that in 2002?
Give a very brief answer. 1.02. What is the ratio of the Area (in %) in Liberia in 1998 to that in 2002?
Provide a succinct answer. 0.98. What is the ratio of the Area (in %) of Paraguay in 1998 to that in 2002?
Your response must be concise. 1. What is the ratio of the Area (in %) in Vietnam in 1998 to that in 2002?
Offer a terse response. 0.81. What is the ratio of the Area (in %) of Bosnia and Herzegovina in 1999 to that in 2000?
Ensure brevity in your answer.  0.99. What is the ratio of the Area (in %) in Liberia in 1999 to that in 2000?
Provide a succinct answer. 0.99. What is the ratio of the Area (in %) in Vietnam in 1999 to that in 2000?
Offer a terse response. 0.92. What is the ratio of the Area (in %) of Bosnia and Herzegovina in 1999 to that in 2001?
Offer a very short reply. 0.99. What is the ratio of the Area (in %) of Liberia in 1999 to that in 2001?
Give a very brief answer. 0.99. What is the ratio of the Area (in %) of Vietnam in 1999 to that in 2001?
Keep it short and to the point. 0.85. What is the ratio of the Area (in %) in Bosnia and Herzegovina in 1999 to that in 2002?
Keep it short and to the point. 0.99. What is the ratio of the Area (in %) in Paraguay in 1999 to that in 2002?
Your answer should be very brief. 1.03. What is the ratio of the Area (in %) of Vietnam in 1999 to that in 2002?
Give a very brief answer. 0.85. What is the ratio of the Area (in %) of Bosnia and Herzegovina in 2000 to that in 2001?
Offer a terse response. 1. What is the ratio of the Area (in %) in Liberia in 2000 to that in 2001?
Give a very brief answer. 1. What is the ratio of the Area (in %) in Vietnam in 2000 to that in 2001?
Your answer should be compact. 0.93. What is the ratio of the Area (in %) of Bosnia and Herzegovina in 2000 to that in 2002?
Provide a succinct answer. 1. What is the ratio of the Area (in %) in Paraguay in 2000 to that in 2002?
Your response must be concise. 1.04. What is the ratio of the Area (in %) in Vietnam in 2000 to that in 2002?
Keep it short and to the point. 0.93. What is the ratio of the Area (in %) in Liberia in 2001 to that in 2002?
Give a very brief answer. 1. What is the ratio of the Area (in %) in Paraguay in 2001 to that in 2002?
Your response must be concise. 1.03. What is the difference between the highest and the second highest Area (in %) of Bosnia and Herzegovina?
Your answer should be compact. 0.1. What is the difference between the highest and the second highest Area (in %) of Paraguay?
Keep it short and to the point. 0.31. What is the difference between the highest and the second highest Area (in %) in Vietnam?
Make the answer very short. 0.04. What is the difference between the highest and the lowest Area (in %) in Bosnia and Herzegovina?
Your answer should be compact. 1.27. What is the difference between the highest and the lowest Area (in %) in Liberia?
Give a very brief answer. 1.14. What is the difference between the highest and the lowest Area (in %) in Paraguay?
Give a very brief answer. 3.28. What is the difference between the highest and the lowest Area (in %) in Vietnam?
Offer a very short reply. 6.88. 